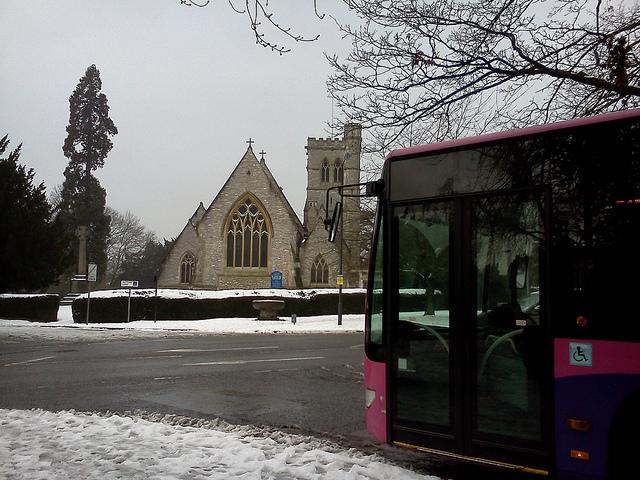What is at the top of the tower?
Answer briefly. Cross. What is the decal on the bus for?
Keep it brief. Handicap. Is there a guy at the bus stop?
Be succinct. No. What is that building opposite to bus?
Answer briefly. Church. Could that be a bus stop across the street?
Keep it brief. Yes. What is on the ground?
Concise answer only. Snow. 